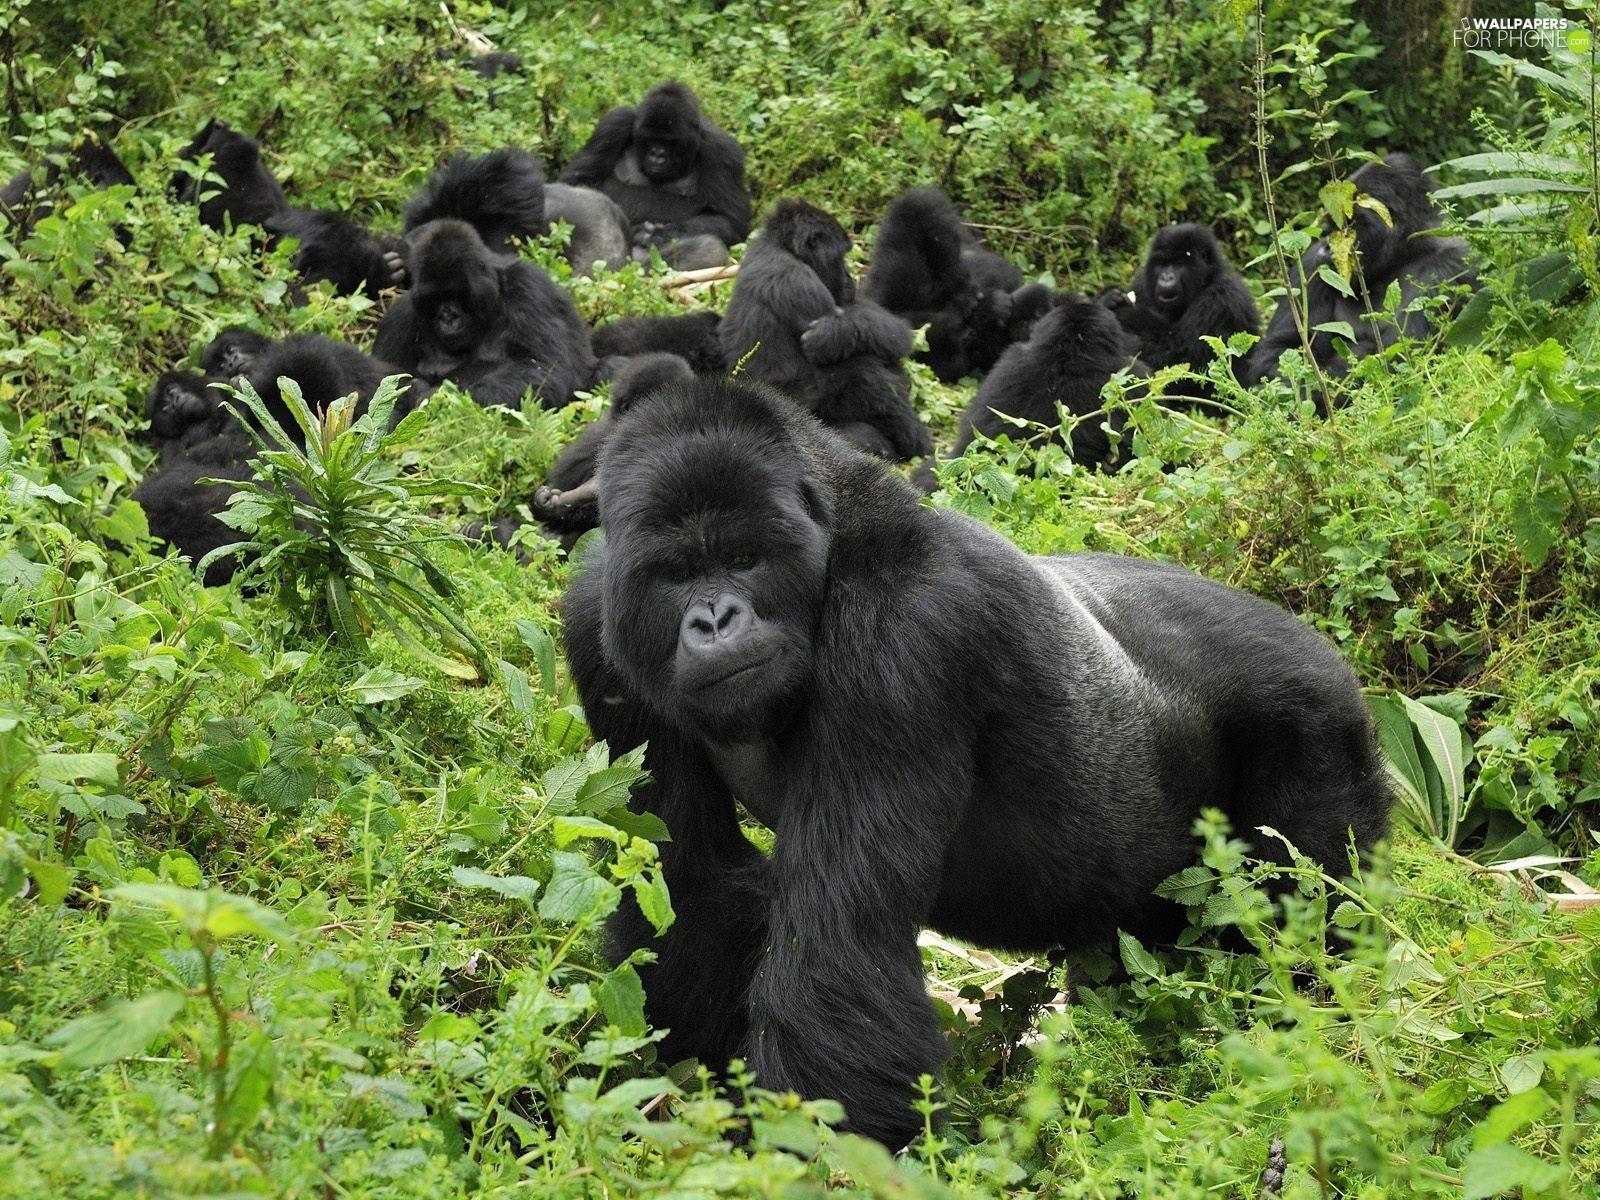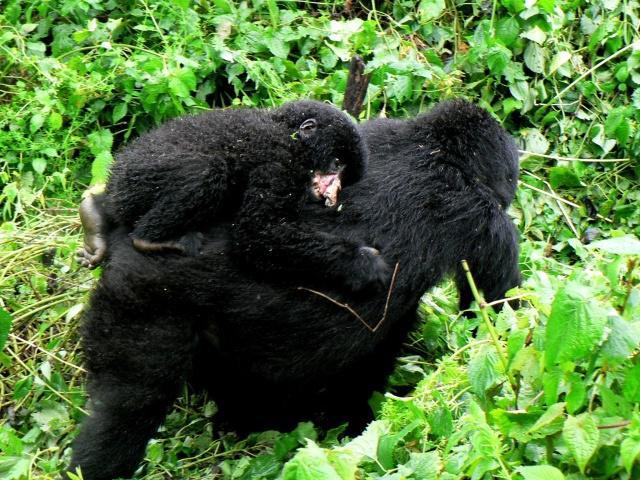The first image is the image on the left, the second image is the image on the right. Considering the images on both sides, is "On one image, a baby gorilla is perched on a bigger gorilla." valid? Answer yes or no. Yes. The first image is the image on the left, the second image is the image on the right. For the images displayed, is the sentence "One image contains at least three times the number of apes as the other image." factually correct? Answer yes or no. Yes. 